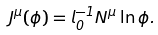Convert formula to latex. <formula><loc_0><loc_0><loc_500><loc_500>J ^ { \mu } ( \phi ) = l _ { 0 } ^ { - 1 } N ^ { \mu } \ln \phi .</formula> 